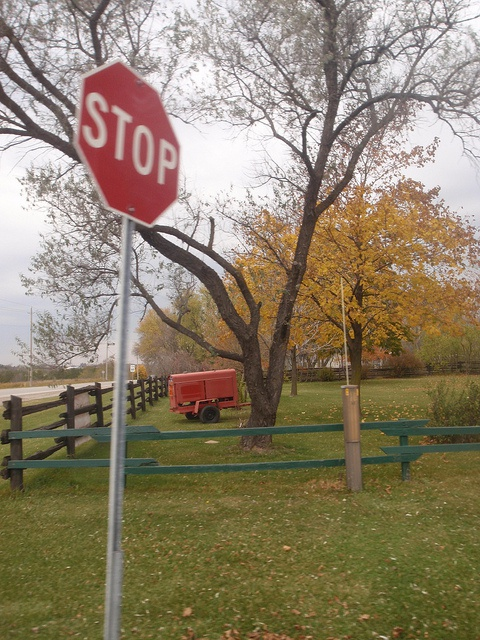Describe the objects in this image and their specific colors. I can see stop sign in gray, brown, and darkgray tones and truck in gray, brown, black, and maroon tones in this image. 